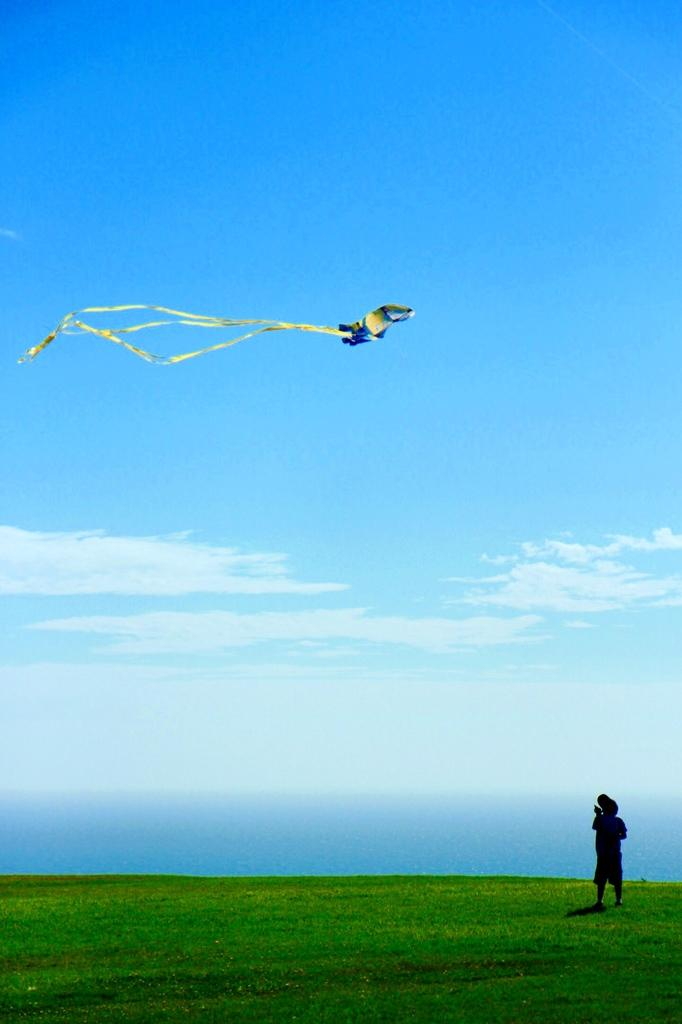What is the main subject of the image? The main subject of the image is a boy. Where is the boy located in the image? The boy is standing on the grass. What activity is the boy engaged in? The boy is flying a kite. What can be seen in the background of the image? The sky is visible in the image. What type of knife can be seen in the boy's hand in the image? There is no knife present in the image; the boy is flying a kite. What emotion does the boy appear to be experiencing while flying the kite? The provided facts do not mention the boy's emotions, so it cannot be determined from the image. 